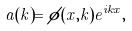<formula> <loc_0><loc_0><loc_500><loc_500>a ( k ) = \phi ( x , k ) e ^ { i k x } ,</formula> 